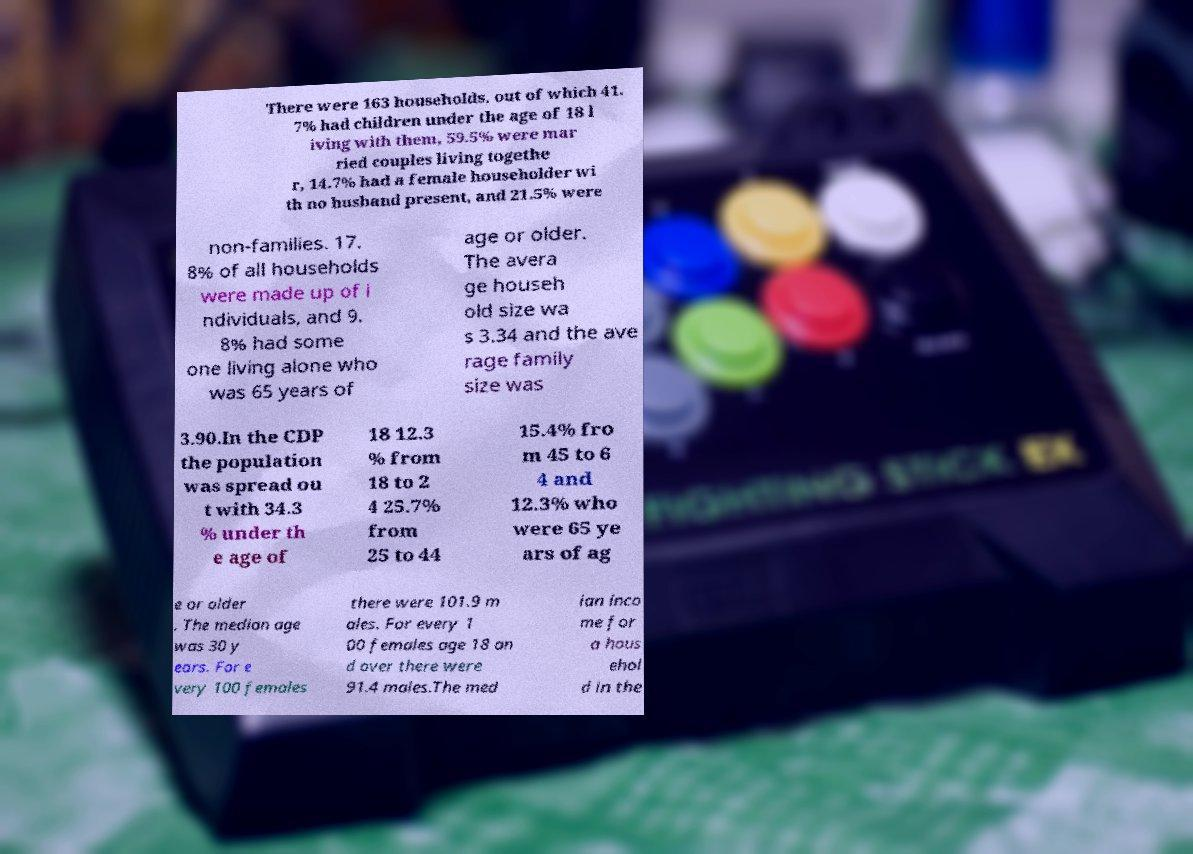Could you assist in decoding the text presented in this image and type it out clearly? There were 163 households, out of which 41. 7% had children under the age of 18 l iving with them, 59.5% were mar ried couples living togethe r, 14.7% had a female householder wi th no husband present, and 21.5% were non-families. 17. 8% of all households were made up of i ndividuals, and 9. 8% had some one living alone who was 65 years of age or older. The avera ge househ old size wa s 3.34 and the ave rage family size was 3.90.In the CDP the population was spread ou t with 34.3 % under th e age of 18 12.3 % from 18 to 2 4 25.7% from 25 to 44 15.4% fro m 45 to 6 4 and 12.3% who were 65 ye ars of ag e or older . The median age was 30 y ears. For e very 100 females there were 101.9 m ales. For every 1 00 females age 18 an d over there were 91.4 males.The med ian inco me for a hous ehol d in the 